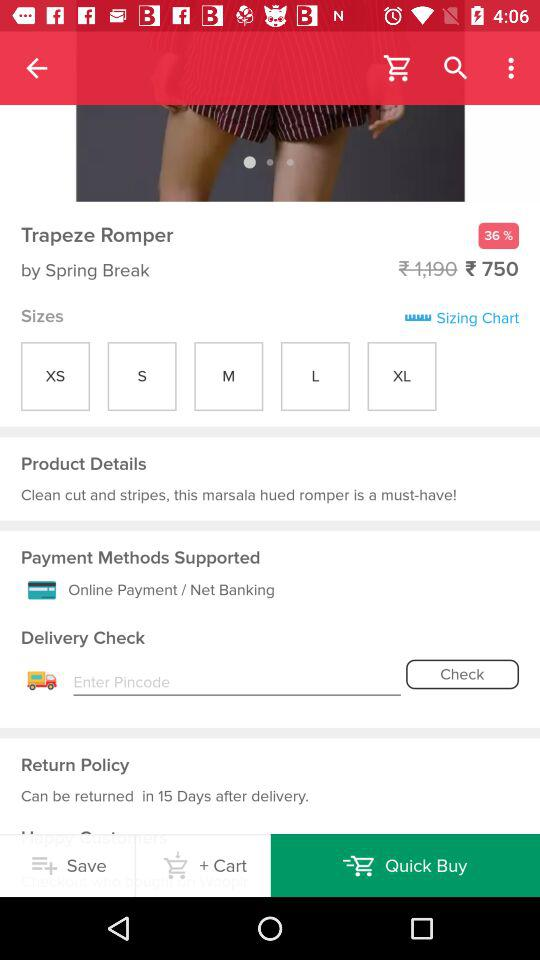What is the price of the Trapeze Romper? The price of the Trapeze Romper is ₹ 750. 